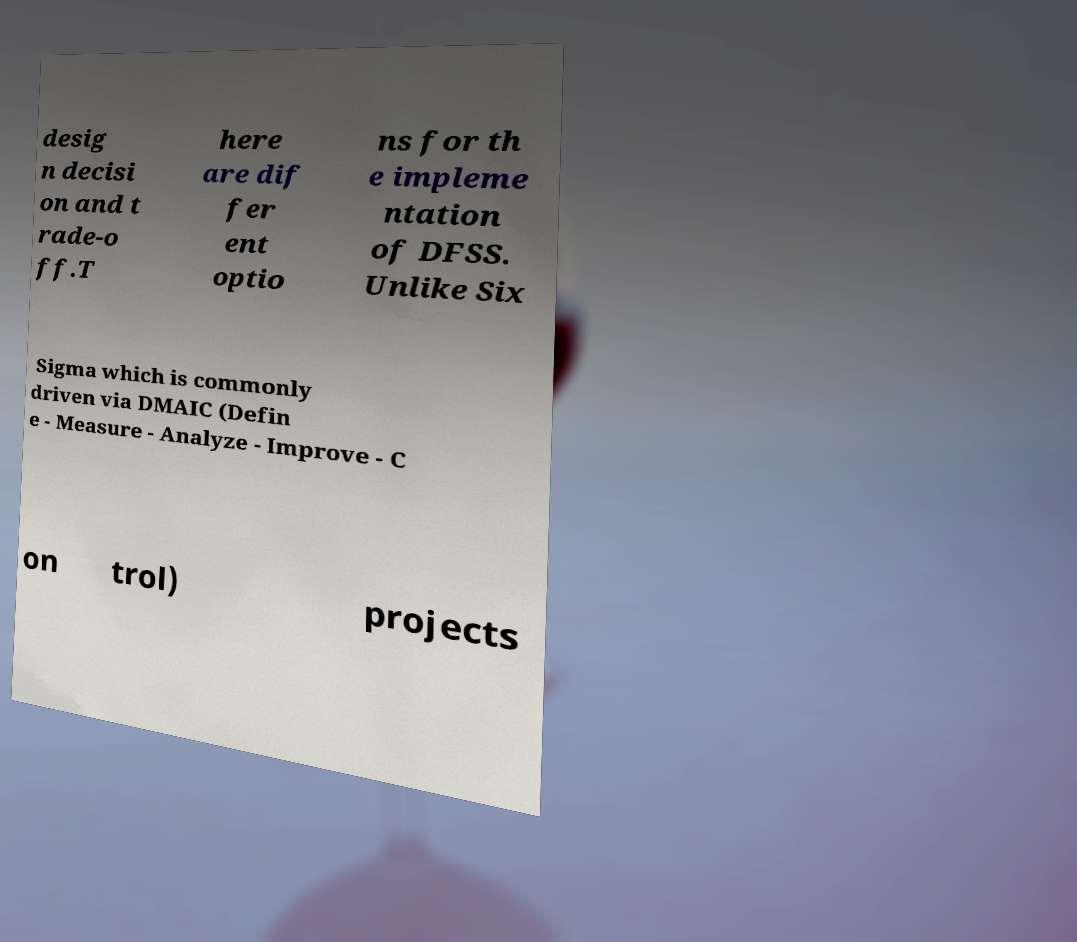I need the written content from this picture converted into text. Can you do that? desig n decisi on and t rade-o ff.T here are dif fer ent optio ns for th e impleme ntation of DFSS. Unlike Six Sigma which is commonly driven via DMAIC (Defin e - Measure - Analyze - Improve - C on trol) projects 